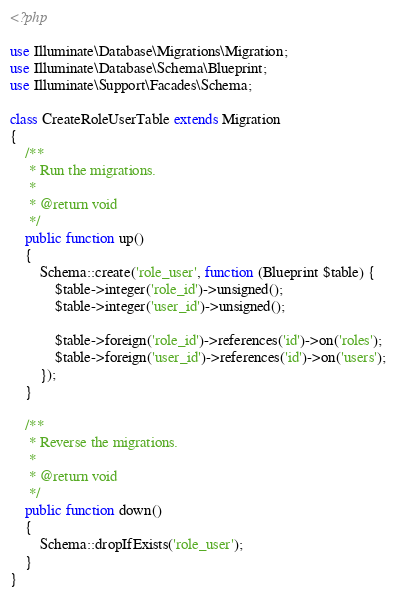Convert code to text. <code><loc_0><loc_0><loc_500><loc_500><_PHP_><?php

use Illuminate\Database\Migrations\Migration;
use Illuminate\Database\Schema\Blueprint;
use Illuminate\Support\Facades\Schema;

class CreateRoleUserTable extends Migration
{
    /**
     * Run the migrations.
     *
     * @return void
     */
    public function up()
    {
        Schema::create('role_user', function (Blueprint $table) {
            $table->integer('role_id')->unsigned();
            $table->integer('user_id')->unsigned();

            $table->foreign('role_id')->references('id')->on('roles');
            $table->foreign('user_id')->references('id')->on('users');
        });
    }

    /**
     * Reverse the migrations.
     *
     * @return void
     */
    public function down()
    {
        Schema::dropIfExists('role_user');
    }
}
</code> 